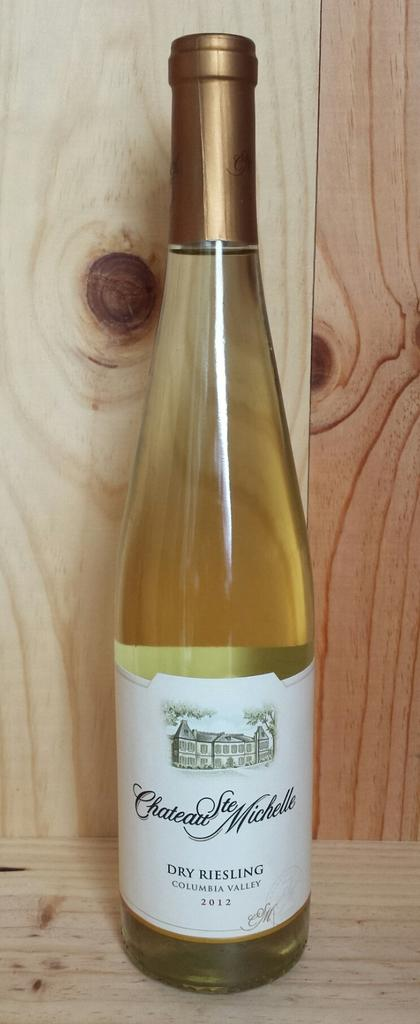<image>
Summarize the visual content of the image. a bottle of Chateau Ste Michelle on a wood surface 